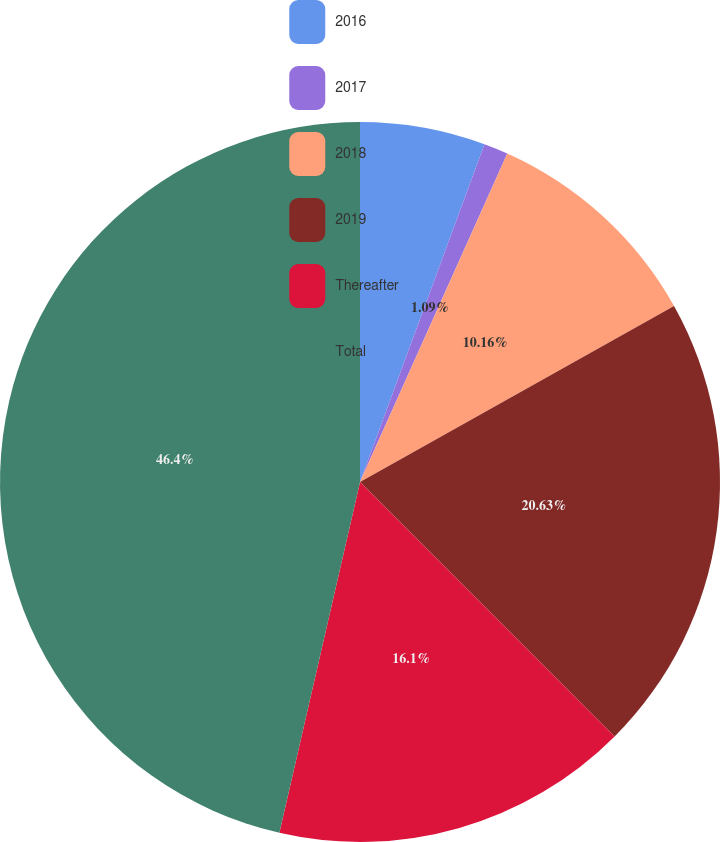Convert chart. <chart><loc_0><loc_0><loc_500><loc_500><pie_chart><fcel>2016<fcel>2017<fcel>2018<fcel>2019<fcel>Thereafter<fcel>Total<nl><fcel>5.62%<fcel>1.09%<fcel>10.16%<fcel>20.63%<fcel>16.1%<fcel>46.41%<nl></chart> 